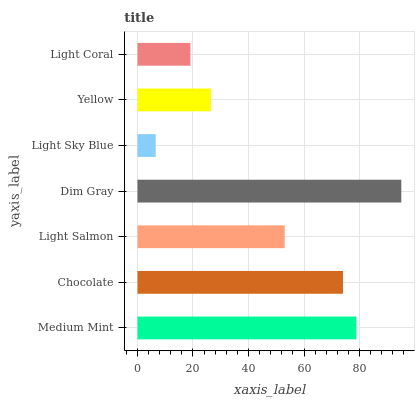Is Light Sky Blue the minimum?
Answer yes or no. Yes. Is Dim Gray the maximum?
Answer yes or no. Yes. Is Chocolate the minimum?
Answer yes or no. No. Is Chocolate the maximum?
Answer yes or no. No. Is Medium Mint greater than Chocolate?
Answer yes or no. Yes. Is Chocolate less than Medium Mint?
Answer yes or no. Yes. Is Chocolate greater than Medium Mint?
Answer yes or no. No. Is Medium Mint less than Chocolate?
Answer yes or no. No. Is Light Salmon the high median?
Answer yes or no. Yes. Is Light Salmon the low median?
Answer yes or no. Yes. Is Dim Gray the high median?
Answer yes or no. No. Is Medium Mint the low median?
Answer yes or no. No. 